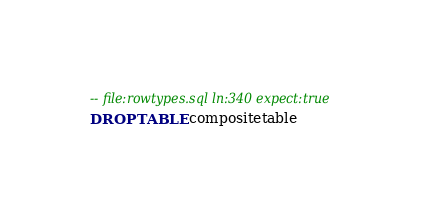Convert code to text. <code><loc_0><loc_0><loc_500><loc_500><_SQL_>-- file:rowtypes.sql ln:340 expect:true
DROP TABLE compositetable
</code> 